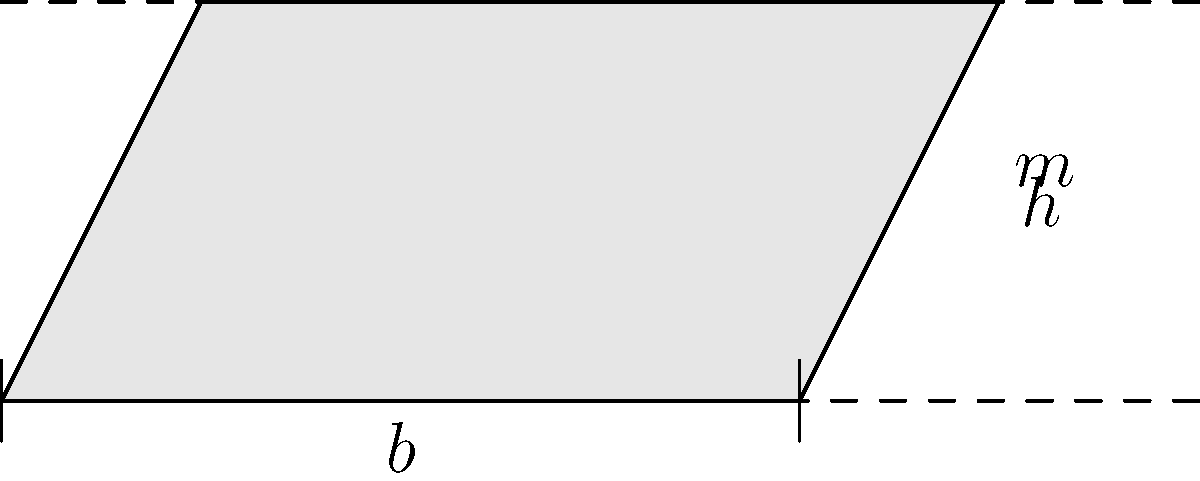As an advocate for education equality, you're analyzing the accessibility of a campus drainage system. An open channel with a trapezoidal cross-section has a bottom width of 4 m, side slopes of 1:2 (horizontal:vertical), and a depth of 2 m. If the channel has a slope of 0.001 and Manning's roughness coefficient is 0.015, what is the flow rate in m³/s? Assume normal flow conditions and use Manning's equation. To solve this problem, we'll use Manning's equation for open channel flow:

$$Q = \frac{1}{n} A R^{2/3} S^{1/2}$$

Where:
$Q$ = flow rate (m³/s)
$n$ = Manning's roughness coefficient (0.015)
$A$ = cross-sectional area (m²)
$R$ = hydraulic radius (m)
$S$ = channel slope (0.001)

Step 1: Calculate the cross-sectional area (A)
Area of trapezoid: $A = (b + mh)h$
Where $b = 4$ m, $m = 1/2$, and $h = 2$ m
$A = (4 + 0.5 \times 2) \times 2 = 10$ m²

Step 2: Calculate the wetted perimeter (P)
$P = b + 2h\sqrt{1+m^2}$
$P = 4 + 2 \times 2 \times \sqrt{1+0.5^2} = 8.47$ m

Step 3: Calculate the hydraulic radius (R)
$R = A/P = 10/8.47 = 1.18$ m

Step 4: Apply Manning's equation
$Q = \frac{1}{0.015} \times 10 \times 1.18^{2/3} \times 0.001^{1/2}$
$Q = 66.67 \times 10 \times 1.12 \times 0.0316$
$Q = 23.6$ m³/s
Answer: 23.6 m³/s 